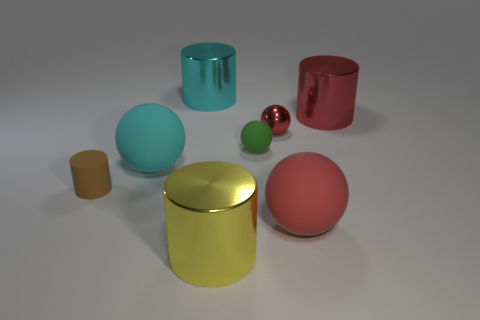How many cylinders are tiny green objects or big shiny objects?
Your answer should be very brief. 3. The rubber sphere that is in front of the big rubber thing that is to the left of the big yellow cylinder is what color?
Make the answer very short. Red. What is the size of the metal object that is the same color as the small metal sphere?
Keep it short and to the point. Large. There is a green sphere that is in front of the shiny object on the left side of the large yellow cylinder; how many matte objects are in front of it?
Keep it short and to the point. 3. Do the red thing that is in front of the cyan sphere and the large matte thing behind the brown cylinder have the same shape?
Keep it short and to the point. Yes. How many objects are small cyan cubes or cyan cylinders?
Ensure brevity in your answer.  1. What material is the large sphere that is to the left of the red ball behind the tiny matte sphere?
Your answer should be very brief. Rubber. Are there any rubber things of the same color as the tiny metal object?
Ensure brevity in your answer.  Yes. There is a rubber object that is the same size as the green rubber sphere; what color is it?
Your answer should be compact. Brown. What is the large cyan thing that is in front of the metallic cylinder behind the big red thing that is behind the red matte ball made of?
Keep it short and to the point. Rubber. 